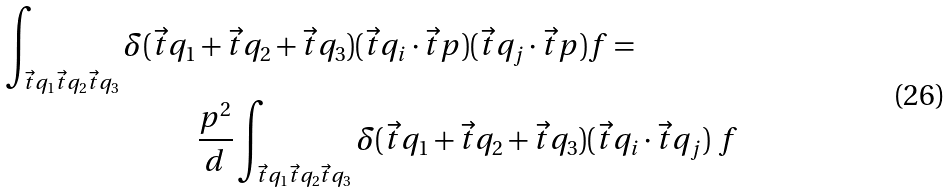<formula> <loc_0><loc_0><loc_500><loc_500>\int _ { \vec { t } q _ { 1 } \vec { t } q _ { 2 } \vec { t } q _ { 3 } } \delta ( \vec { t } q _ { 1 } & + \vec { t } q _ { 2 } + \vec { t } q _ { 3 } ) ( \vec { t } q _ { i } \cdot \vec { t } p ) ( \vec { t } q _ { j } \cdot \vec { t } p ) f = \\ & \frac { p ^ { 2 } } d \int _ { \vec { t } q _ { 1 } \vec { t } q _ { 2 } \vec { t } q _ { 3 } } \delta ( \vec { t } q _ { 1 } + \vec { t } q _ { 2 } + \vec { t } q _ { 3 } ) ( \vec { t } q _ { i } \cdot \vec { t } q _ { j } ) \ f</formula> 